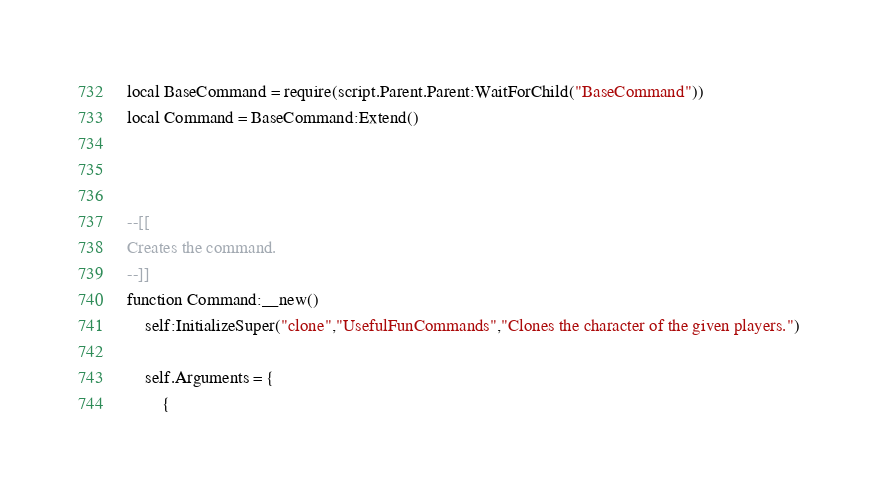Convert code to text. <code><loc_0><loc_0><loc_500><loc_500><_Lua_>local BaseCommand = require(script.Parent.Parent:WaitForChild("BaseCommand"))
local Command = BaseCommand:Extend()



--[[
Creates the command.
--]]
function Command:__new()
    self:InitializeSuper("clone","UsefulFunCommands","Clones the character of the given players.")

    self.Arguments = {
        {</code> 